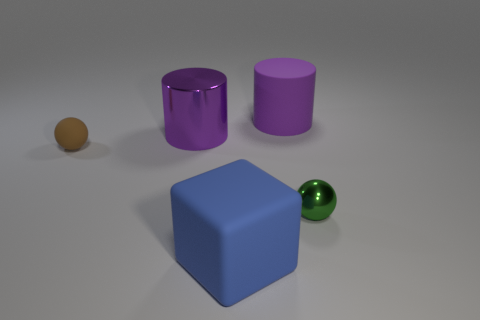Add 3 tiny cyan metallic balls. How many objects exist? 8 Subtract all cylinders. How many objects are left? 3 Add 5 purple cylinders. How many purple cylinders exist? 7 Subtract 0 cyan cylinders. How many objects are left? 5 Subtract all small brown spheres. Subtract all cubes. How many objects are left? 3 Add 2 big things. How many big things are left? 5 